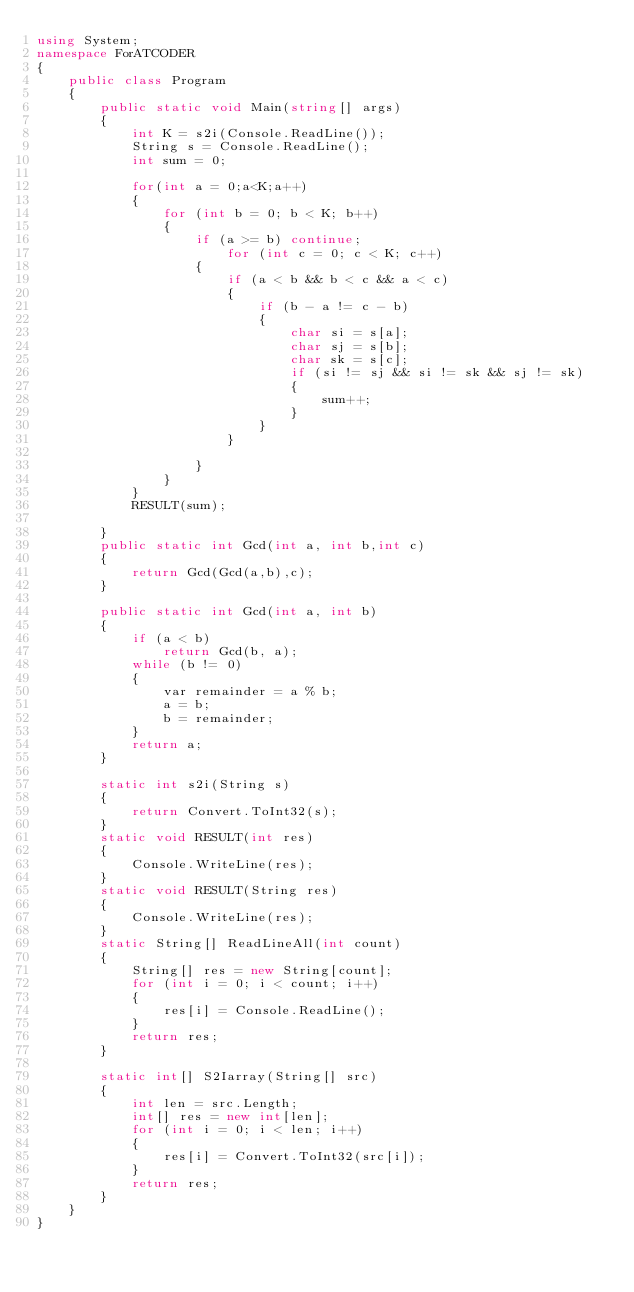<code> <loc_0><loc_0><loc_500><loc_500><_C#_>using System;
namespace ForATCODER
{
    public class Program
    {
        public static void Main(string[] args)
        {
            int K = s2i(Console.ReadLine());
            String s = Console.ReadLine();
            int sum = 0;

            for(int a = 0;a<K;a++)
            {
                for (int b = 0; b < K; b++)
                {
                    if (a >= b) continue;
                        for (int c = 0; c < K; c++)
                    {
                        if (a < b && b < c && a < c)
                        {
                            if (b - a != c - b)
                            {
                                char si = s[a];
                                char sj = s[b];
                                char sk = s[c];
                                if (si != sj && si != sk && sj != sk)
                                {
                                    sum++;
                                }
                            }
                        }
                       
                    }
                }
            }
            RESULT(sum);
                 
        }
        public static int Gcd(int a, int b,int c)
        {
            return Gcd(Gcd(a,b),c);
        }

        public static int Gcd(int a, int b)
        {
            if (a < b)
                return Gcd(b, a);
            while (b != 0)
            {
                var remainder = a % b;
                a = b;
                b = remainder;
            }
            return a;
        }

        static int s2i(String s)
        {
            return Convert.ToInt32(s);
        }
        static void RESULT(int res)
        {
            Console.WriteLine(res);
        }
        static void RESULT(String res)
        {
            Console.WriteLine(res);
        }
        static String[] ReadLineAll(int count)
        {
            String[] res = new String[count];
            for (int i = 0; i < count; i++)
            {
                res[i] = Console.ReadLine(); 
            }
            return res;
        }

        static int[] S2Iarray(String[] src)
        {
            int len = src.Length;
            int[] res = new int[len];
            for (int i = 0; i < len; i++)
            {
                res[i] = Convert.ToInt32(src[i]);
            }
            return res;
        }
    }
}</code> 